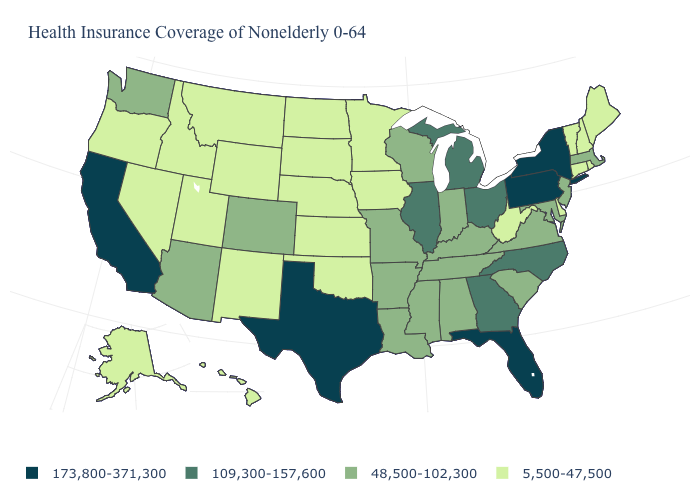Does New Jersey have a higher value than Arkansas?
Give a very brief answer. No. Among the states that border Virginia , which have the lowest value?
Write a very short answer. West Virginia. Which states hav the highest value in the MidWest?
Give a very brief answer. Illinois, Michigan, Ohio. Which states have the highest value in the USA?
Be succinct. California, Florida, New York, Pennsylvania, Texas. Among the states that border New Jersey , does Delaware have the highest value?
Quick response, please. No. What is the value of Hawaii?
Write a very short answer. 5,500-47,500. What is the value of Montana?
Quick response, please. 5,500-47,500. Among the states that border Wyoming , which have the highest value?
Give a very brief answer. Colorado. Name the states that have a value in the range 109,300-157,600?
Be succinct. Georgia, Illinois, Michigan, North Carolina, Ohio. Name the states that have a value in the range 5,500-47,500?
Answer briefly. Alaska, Connecticut, Delaware, Hawaii, Idaho, Iowa, Kansas, Maine, Minnesota, Montana, Nebraska, Nevada, New Hampshire, New Mexico, North Dakota, Oklahoma, Oregon, Rhode Island, South Dakota, Utah, Vermont, West Virginia, Wyoming. What is the value of Pennsylvania?
Keep it brief. 173,800-371,300. Which states hav the highest value in the West?
Concise answer only. California. Name the states that have a value in the range 5,500-47,500?
Give a very brief answer. Alaska, Connecticut, Delaware, Hawaii, Idaho, Iowa, Kansas, Maine, Minnesota, Montana, Nebraska, Nevada, New Hampshire, New Mexico, North Dakota, Oklahoma, Oregon, Rhode Island, South Dakota, Utah, Vermont, West Virginia, Wyoming. What is the value of North Dakota?
Concise answer only. 5,500-47,500. Among the states that border Indiana , which have the lowest value?
Write a very short answer. Kentucky. 